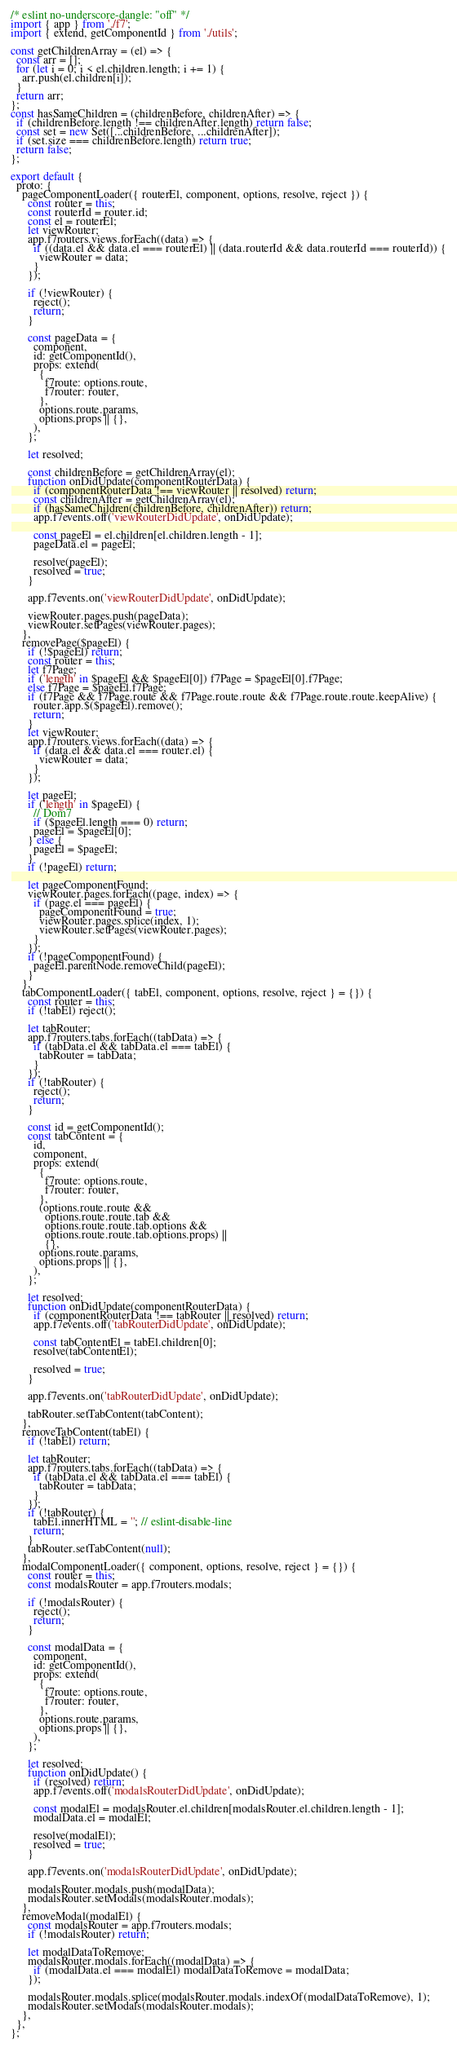Convert code to text. <code><loc_0><loc_0><loc_500><loc_500><_JavaScript_>/* eslint no-underscore-dangle: "off" */
import { app } from './f7';
import { extend, getComponentId } from './utils';

const getChildrenArray = (el) => {
  const arr = [];
  for (let i = 0; i < el.children.length; i += 1) {
    arr.push(el.children[i]);
  }
  return arr;
};
const hasSameChildren = (childrenBefore, childrenAfter) => {
  if (childrenBefore.length !== childrenAfter.length) return false;
  const set = new Set([...childrenBefore, ...childrenAfter]);
  if (set.size === childrenBefore.length) return true;
  return false;
};

export default {
  proto: {
    pageComponentLoader({ routerEl, component, options, resolve, reject }) {
      const router = this;
      const routerId = router.id;
      const el = routerEl;
      let viewRouter;
      app.f7routers.views.forEach((data) => {
        if ((data.el && data.el === routerEl) || (data.routerId && data.routerId === routerId)) {
          viewRouter = data;
        }
      });

      if (!viewRouter) {
        reject();
        return;
      }

      const pageData = {
        component,
        id: getComponentId(),
        props: extend(
          {
            f7route: options.route,
            f7router: router,
          },
          options.route.params,
          options.props || {},
        ),
      };

      let resolved;

      const childrenBefore = getChildrenArray(el);
      function onDidUpdate(componentRouterData) {
        if (componentRouterData !== viewRouter || resolved) return;
        const childrenAfter = getChildrenArray(el);
        if (hasSameChildren(childrenBefore, childrenAfter)) return;
        app.f7events.off('viewRouterDidUpdate', onDidUpdate);

        const pageEl = el.children[el.children.length - 1];
        pageData.el = pageEl;

        resolve(pageEl);
        resolved = true;
      }

      app.f7events.on('viewRouterDidUpdate', onDidUpdate);

      viewRouter.pages.push(pageData);
      viewRouter.setPages(viewRouter.pages);
    },
    removePage($pageEl) {
      if (!$pageEl) return;
      const router = this;
      let f7Page;
      if ('length' in $pageEl && $pageEl[0]) f7Page = $pageEl[0].f7Page;
      else f7Page = $pageEl.f7Page;
      if (f7Page && f7Page.route && f7Page.route.route && f7Page.route.route.keepAlive) {
        router.app.$($pageEl).remove();
        return;
      }
      let viewRouter;
      app.f7routers.views.forEach((data) => {
        if (data.el && data.el === router.el) {
          viewRouter = data;
        }
      });

      let pageEl;
      if ('length' in $pageEl) {
        // Dom7
        if ($pageEl.length === 0) return;
        pageEl = $pageEl[0];
      } else {
        pageEl = $pageEl;
      }
      if (!pageEl) return;

      let pageComponentFound;
      viewRouter.pages.forEach((page, index) => {
        if (page.el === pageEl) {
          pageComponentFound = true;
          viewRouter.pages.splice(index, 1);
          viewRouter.setPages(viewRouter.pages);
        }
      });
      if (!pageComponentFound) {
        pageEl.parentNode.removeChild(pageEl);
      }
    },
    tabComponentLoader({ tabEl, component, options, resolve, reject } = {}) {
      const router = this;
      if (!tabEl) reject();

      let tabRouter;
      app.f7routers.tabs.forEach((tabData) => {
        if (tabData.el && tabData.el === tabEl) {
          tabRouter = tabData;
        }
      });
      if (!tabRouter) {
        reject();
        return;
      }

      const id = getComponentId();
      const tabContent = {
        id,
        component,
        props: extend(
          {
            f7route: options.route,
            f7router: router,
          },
          (options.route.route &&
            options.route.route.tab &&
            options.route.route.tab.options &&
            options.route.route.tab.options.props) ||
            {},
          options.route.params,
          options.props || {},
        ),
      };

      let resolved;
      function onDidUpdate(componentRouterData) {
        if (componentRouterData !== tabRouter || resolved) return;
        app.f7events.off('tabRouterDidUpdate', onDidUpdate);

        const tabContentEl = tabEl.children[0];
        resolve(tabContentEl);

        resolved = true;
      }

      app.f7events.on('tabRouterDidUpdate', onDidUpdate);

      tabRouter.setTabContent(tabContent);
    },
    removeTabContent(tabEl) {
      if (!tabEl) return;

      let tabRouter;
      app.f7routers.tabs.forEach((tabData) => {
        if (tabData.el && tabData.el === tabEl) {
          tabRouter = tabData;
        }
      });
      if (!tabRouter) {
        tabEl.innerHTML = ''; // eslint-disable-line
        return;
      }
      tabRouter.setTabContent(null);
    },
    modalComponentLoader({ component, options, resolve, reject } = {}) {
      const router = this;
      const modalsRouter = app.f7routers.modals;

      if (!modalsRouter) {
        reject();
        return;
      }

      const modalData = {
        component,
        id: getComponentId(),
        props: extend(
          {
            f7route: options.route,
            f7router: router,
          },
          options.route.params,
          options.props || {},
        ),
      };

      let resolved;
      function onDidUpdate() {
        if (resolved) return;
        app.f7events.off('modalsRouterDidUpdate', onDidUpdate);

        const modalEl = modalsRouter.el.children[modalsRouter.el.children.length - 1];
        modalData.el = modalEl;

        resolve(modalEl);
        resolved = true;
      }

      app.f7events.on('modalsRouterDidUpdate', onDidUpdate);

      modalsRouter.modals.push(modalData);
      modalsRouter.setModals(modalsRouter.modals);
    },
    removeModal(modalEl) {
      const modalsRouter = app.f7routers.modals;
      if (!modalsRouter) return;

      let modalDataToRemove;
      modalsRouter.modals.forEach((modalData) => {
        if (modalData.el === modalEl) modalDataToRemove = modalData;
      });

      modalsRouter.modals.splice(modalsRouter.modals.indexOf(modalDataToRemove), 1);
      modalsRouter.setModals(modalsRouter.modals);
    },
  },
};
</code> 